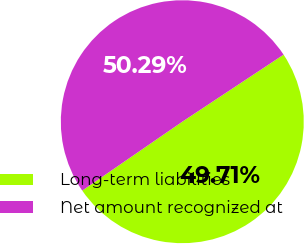Convert chart to OTSL. <chart><loc_0><loc_0><loc_500><loc_500><pie_chart><fcel>Long-term liabilities<fcel>Net amount recognized at<nl><fcel>49.71%<fcel>50.29%<nl></chart> 